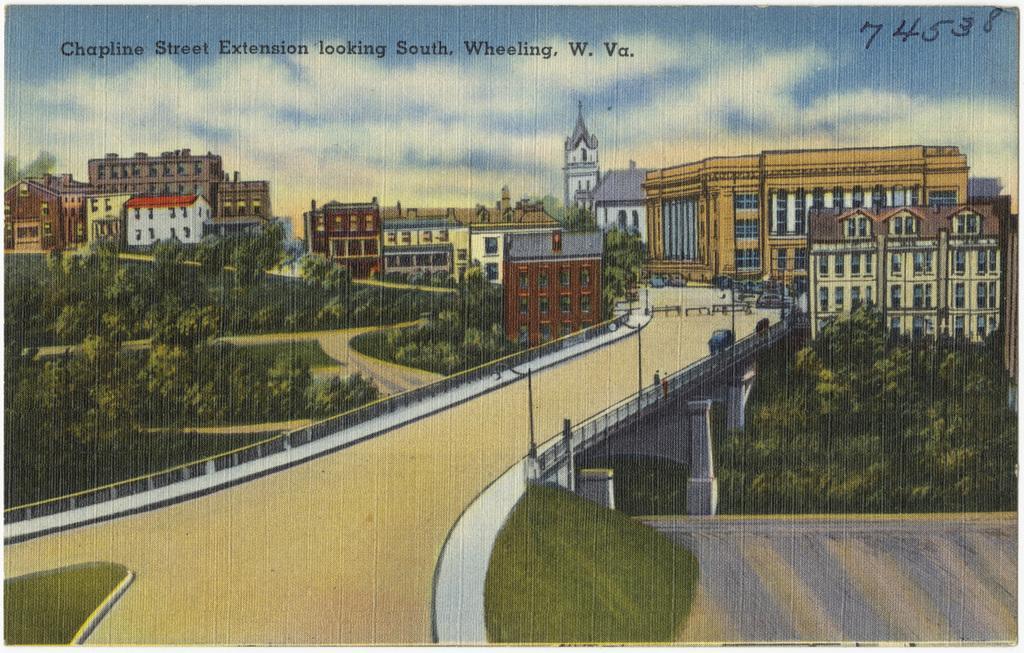Please provide a concise description of this image. In this image we can see the picture of the buildings, some people on the pathway, a group of trees, grass, poles and the sky which looks cloudy. On the top of the image we can see some text and written numbers on it. 